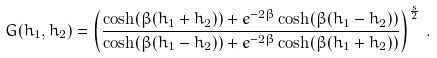Convert formula to latex. <formula><loc_0><loc_0><loc_500><loc_500>G ( h _ { 1 } , h _ { 2 } ) = \left ( \frac { \cosh ( \beta ( h _ { 1 } + h _ { 2 } ) ) + e ^ { - 2 \beta } \cosh ( \beta ( h _ { 1 } - h _ { 2 } ) ) } { \cosh ( \beta ( h _ { 1 } - h _ { 2 } ) ) + e ^ { - 2 \beta } \cosh ( \beta ( h _ { 1 } + h _ { 2 } ) ) } \right ) ^ { \frac { s } { 2 } } \, .</formula> 